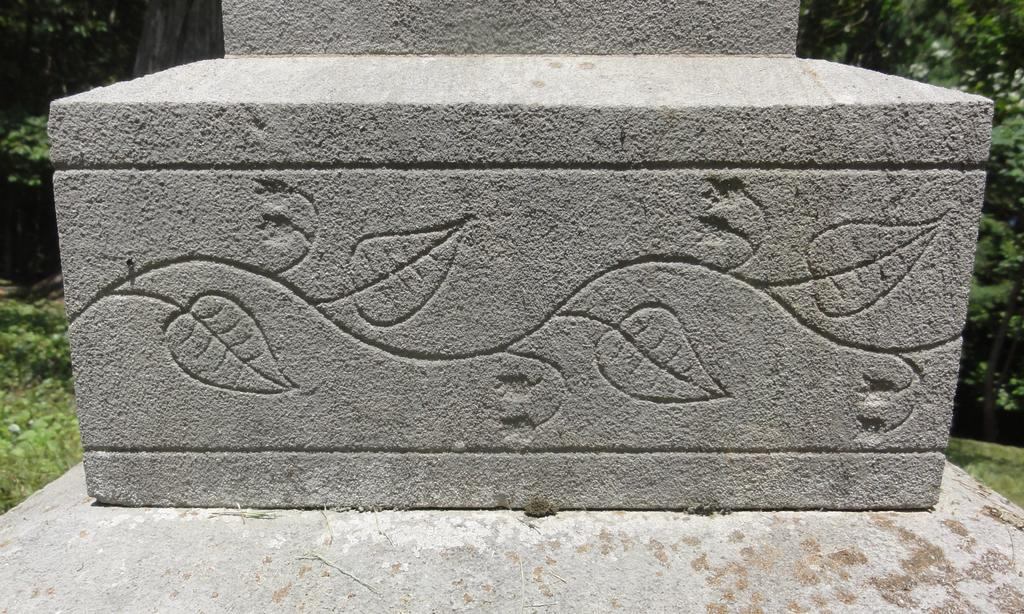What is the main object in the image? There is a concrete block in the image. What type of natural environment is visible in the image? There is grass visible in the image. What other natural elements can be seen in the image? There are trees in the image. What type of straw is being used to construct the concrete block in the image? There is no straw present in the image, and the concrete block is not being constructed. What type of throne is visible in the image? There is no throne present in the image. 